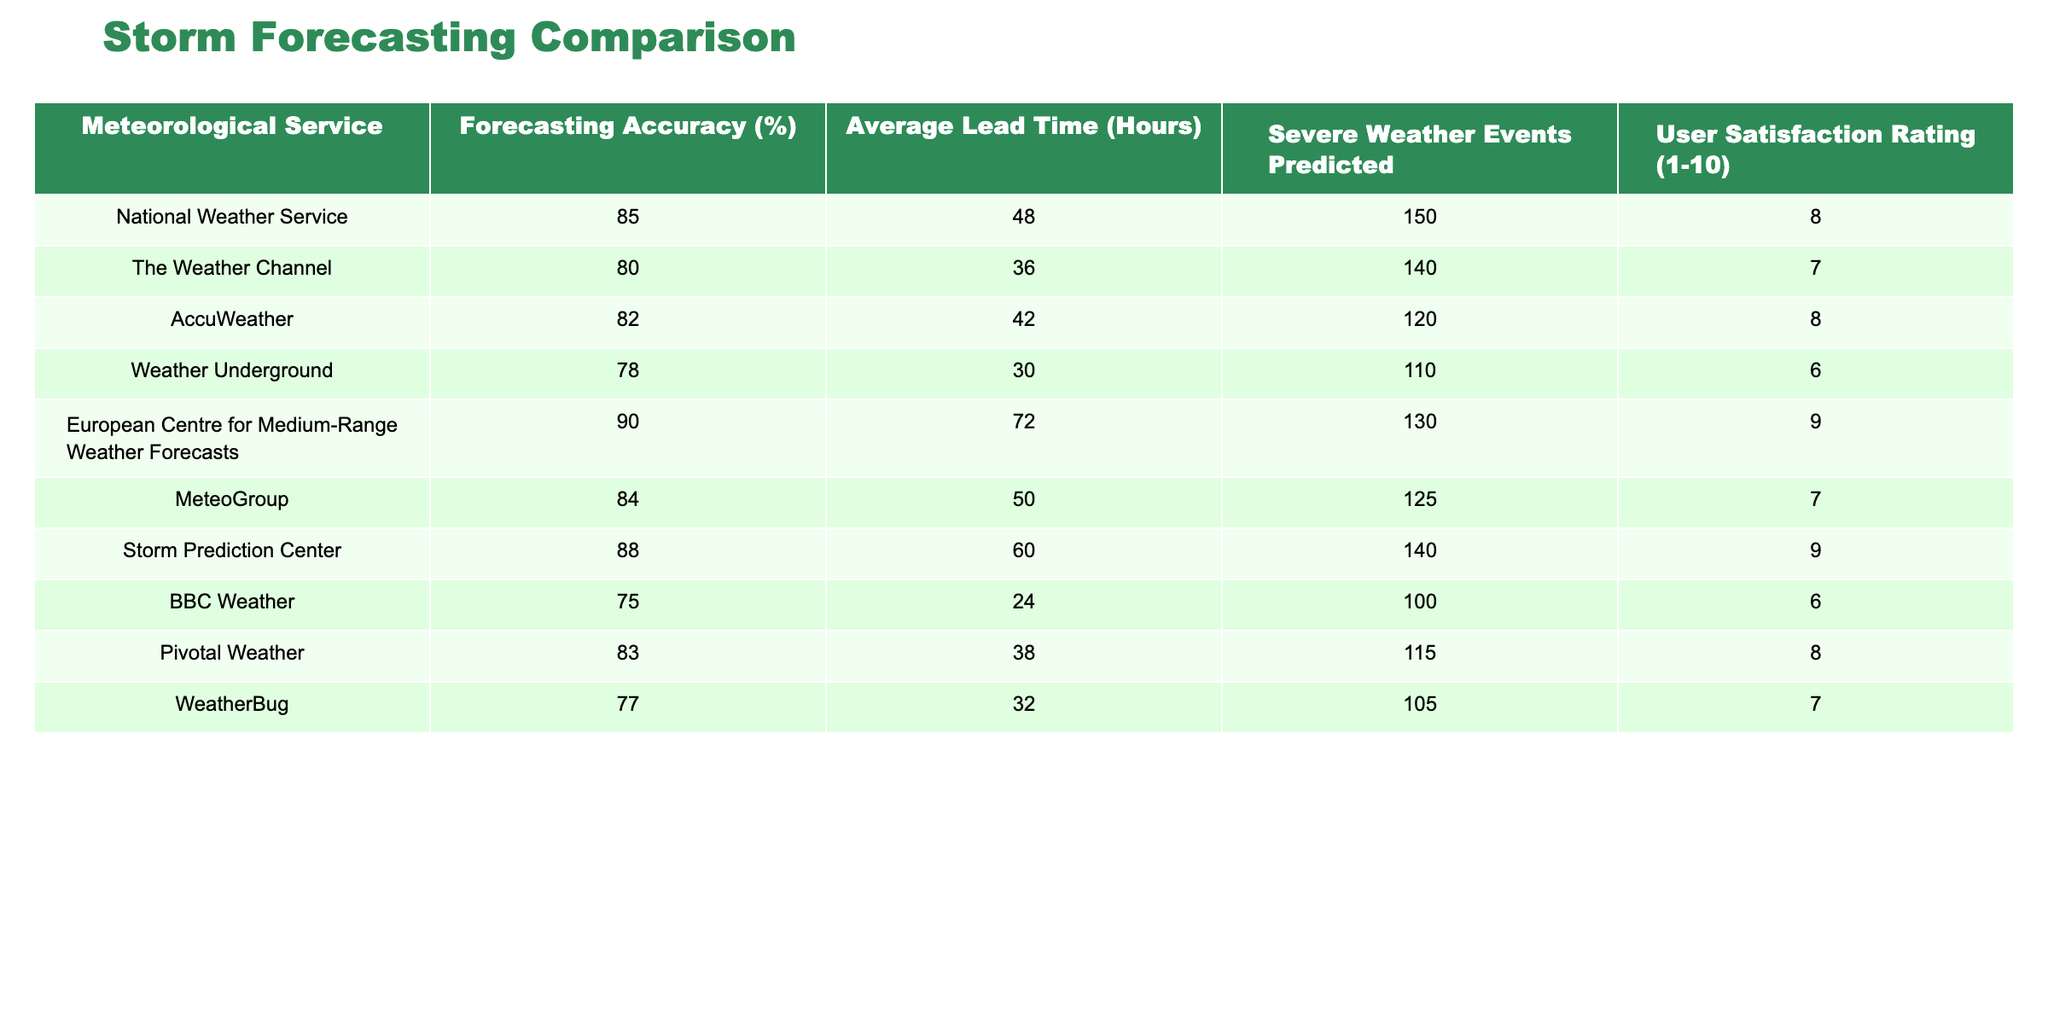What is the highest forecasting accuracy among the meteorological services? The highest value in the "Forecasting Accuracy (%)" column is 90, which belongs to the European Centre for Medium-Range Weather Forecasts.
Answer: 90 Which meteorological service has the lowest user satisfaction rating? Looking at the "User Satisfaction Rating (1-10)" column, the lowest value is 6, which is shared by Weather Underground and BBC Weather.
Answer: Weather Underground and BBC Weather What is the average lead time across all the services? To find the average lead time, sum all values in the "Average Lead Time (Hours)" column (48 + 36 + 42 + 30 + 72 + 50 + 60 + 24 + 38 + 32 = 432) and divide by the number of services (10). So, the average lead time is 432 / 10 = 43.2 hours.
Answer: 43.2 hours Which service predicted the most severe weather events? The "Severe Weather Events Predicted" column shows the highest value is 150, attributed to the National Weather Service.
Answer: National Weather Service Is the forecasting accuracy of the Storm Prediction Center greater than the average accuracy of all services? First, calculate the average accuracy by summing all service accuracies (85 + 80 + 82 + 78 + 90 + 84 + 88 + 75 + 83 + 77 = 83.7) and dividing by the number of services (10), which results in an average of 83.7. The Storm Prediction Center has an accuracy of 88, which is greater than 83.7.
Answer: Yes Which service has the lowest average lead time, and what is that time? The "Average Lead Time (Hours)" column indicates that BBC Weather has the lowest average lead time at 24 hours.
Answer: BBC Weather, 24 hours How many more severe weather events did the National Weather Service predict compared to the Weather Underground? The National Weather Service predicted 150 events, while Weather Underground predicted 110 events. The difference is 150 - 110 = 40.
Answer: 40 events Which meteorological service has a user satisfaction rating higher than 8 and what is its accuracy? Both the European Centre for Medium-Range Weather Forecasts and the Storm Prediction Center have user satisfaction ratings of 9, with forecasting accuracies of 90% and 88%, respectively.
Answer: European Centre for Medium-Range Weather Forecasts, 90% What is the total severe weather events predicted by all services? The total can be calculated by summing the values in the "Severe Weather Events Predicted" column (150 + 140 + 120 + 110 + 130 + 125 + 140 + 100 + 115 + 105 = 1,250).
Answer: 1,250 events Does AccuWeather have a greater lead time than The Weather Channel? AccuWeather has an average lead time of 42 hours, while The Weather Channel has 36 hours, which means AccuWeather's lead time is indeed greater.
Answer: Yes 